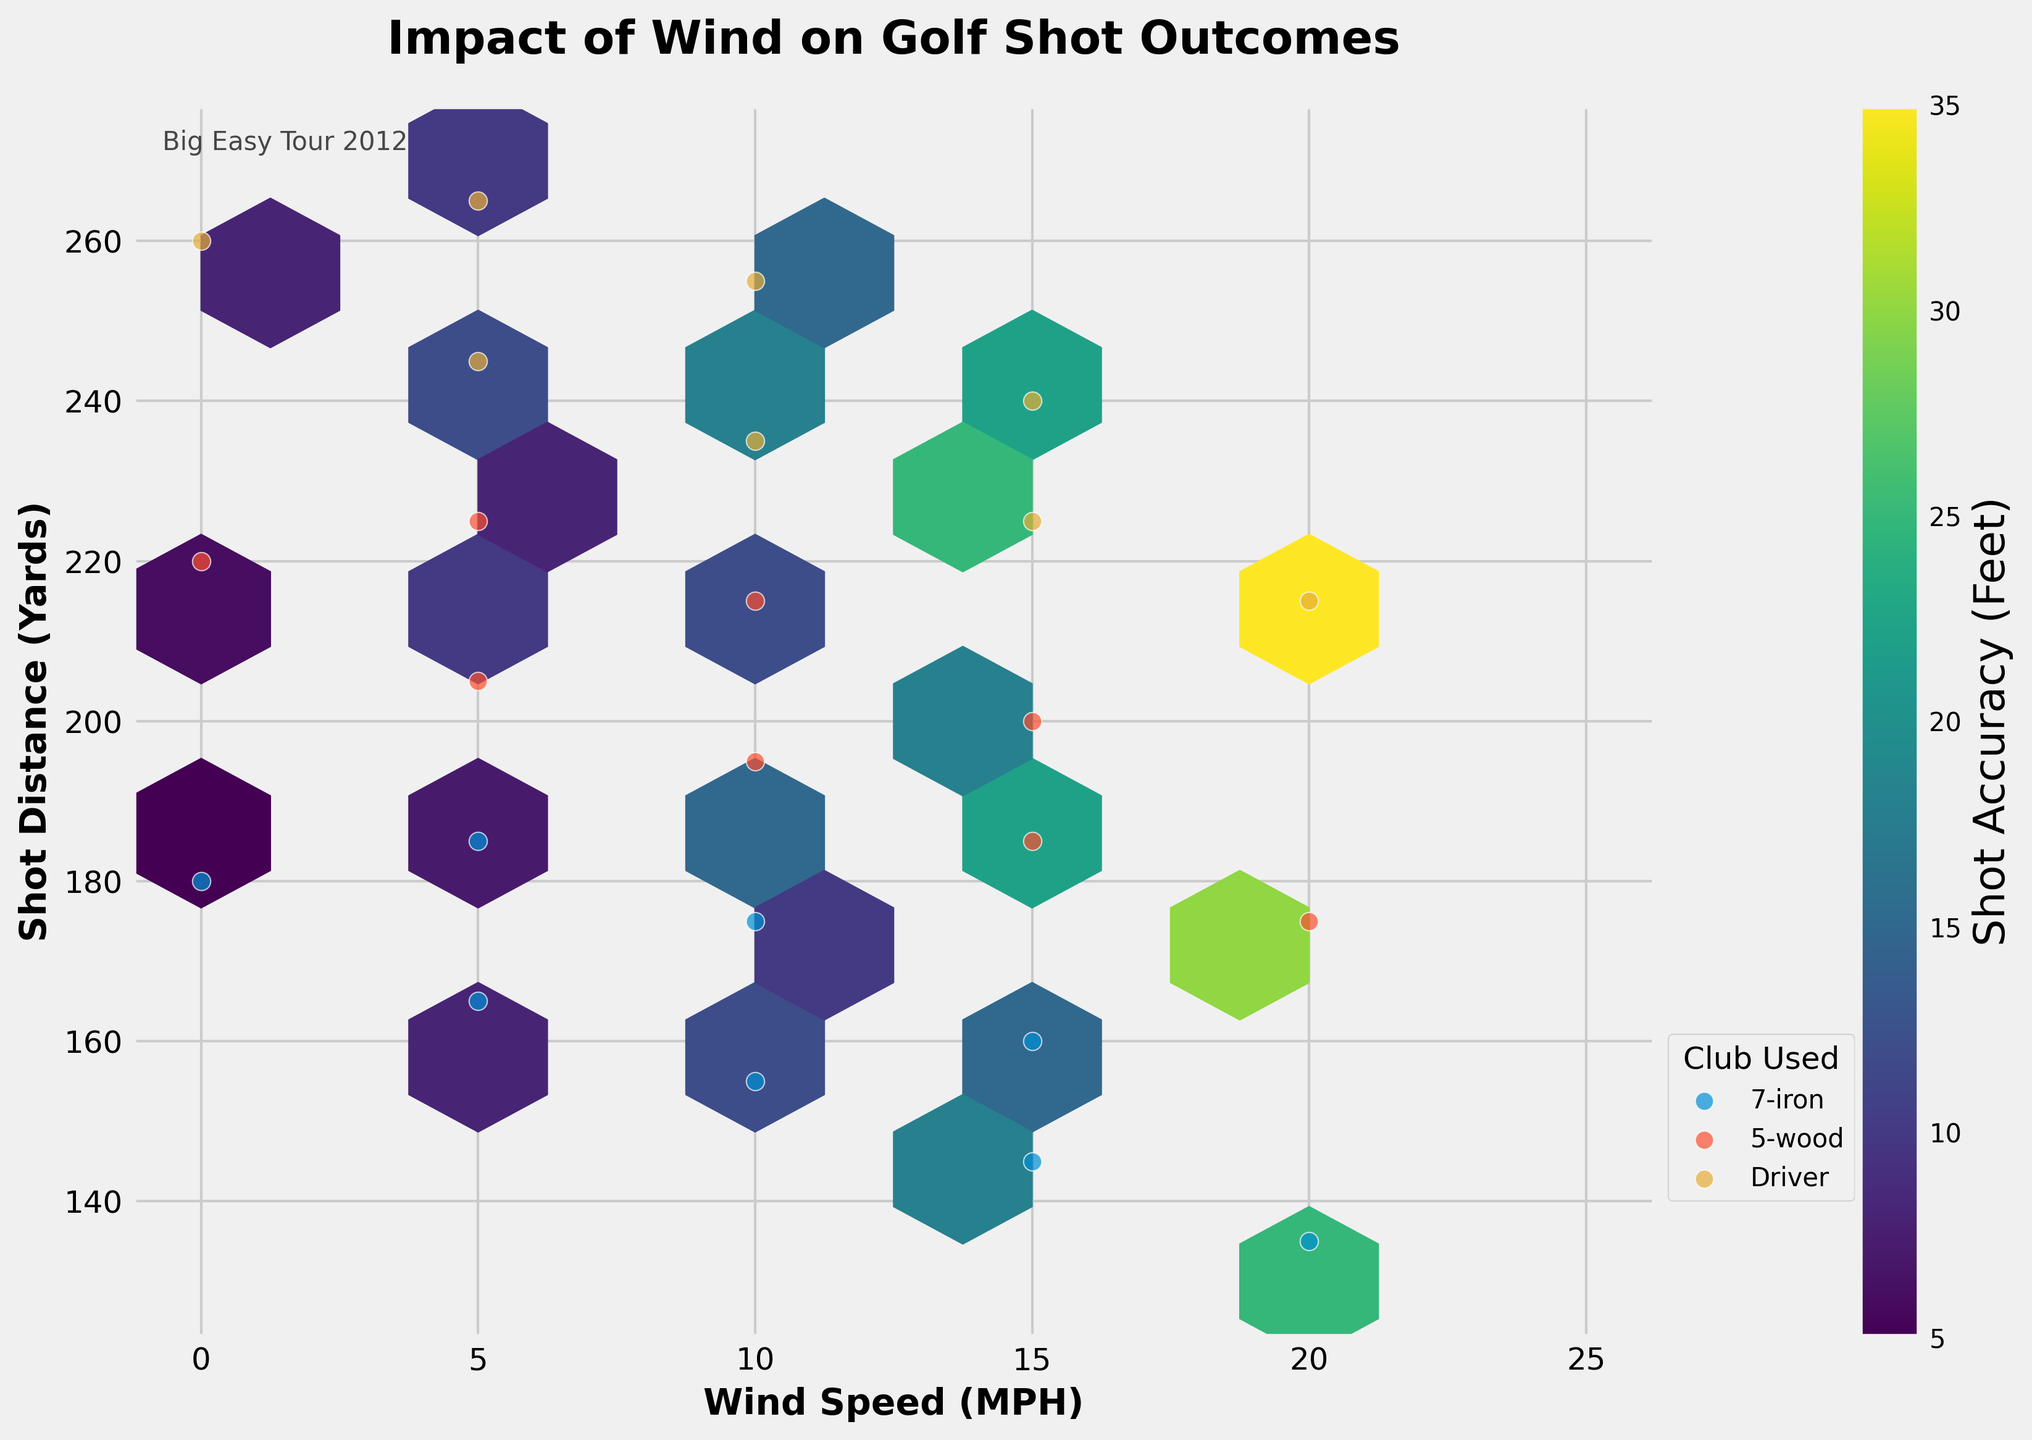How does wind speed affect shot distance based on the plot? By observing the slope of the hexbin clusters, we can infer that as wind speed increases, shot distance generally decreases. This is evidenced by the darker regions moving downward as wind speed increases.
Answer: Inversely related What is the range of shot accuracies represented in the color bar? The color bar on the right indicates shot accuracy in feet, with values ranging from about 5 feet to 35 feet.
Answer: 5 to 35 feet Which type of club shows the longest shot distances? The 'Driver' club shows the longest shot distances, as evidenced by the green dots located furthest to the right along the shot distance axis.
Answer: Driver How does the shot accuracy compare between the 'Driver' and '7-iron'? By comparing the colors, 'Driver' shots appear to have larger shot inaccuracies (darker colors) compared to '7-iron' shots, which have lighter colors indicating better accuracy.
Answer: Lower accuracy for Driver Is there a specific wind direction that seems to affect shot accuracy the most? Observing the hexbin colors, when the wind comes from the south (S), there is a noticeable decrease in shot accuracy indicated by darker tones.
Answer: South Do the plots show any outliers where the shot distance is significantly different from the trend? Yes, there are a few outlier points, particularly for 'Driver' shots at lower wind speeds, where the shot distances are higher than the general trend.
Answer: Yes What is the relationship between wind direction and your shot distance using a 7-iron? Shots taken with a 7-iron generally have greater distances when the wind is strong and hitting from behind the golfer (NW and W directions). Distances decrease when the wind is from the south.
Answer: Relatively high for NW/W, low for S How does the shot accuracy change as the wind speed increases from 0 to 20 MPH? Against stronger wind speeds, shot accuracy deteriorates, as shown by the increasing darkness in the hexbin plots reflecting higher inaccuracies.
Answer: Decreases What does the grid size in hexbin represent, and what is it set to? The grid size in the hexbin plot determines the resolution of the bins and how data is aggregated. The grid size is set to 10, resulting in a detailed but not overly complex plot.
Answer: 10 Is there any wind speed where the data points are sparsely populated? Yes, data points are less concentrated at the higher wind speeds (20 MPH) based on the spacing and fewer clusters.
Answer: Yes 